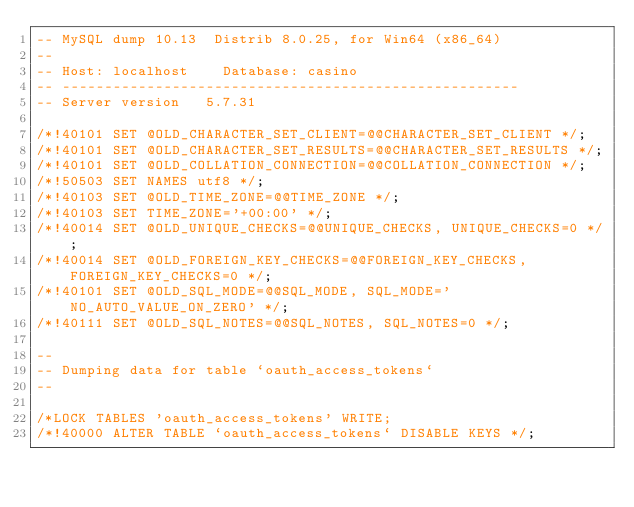<code> <loc_0><loc_0><loc_500><loc_500><_SQL_>-- MySQL dump 10.13  Distrib 8.0.25, for Win64 (x86_64)
--
-- Host: localhost    Database: casino
-- ------------------------------------------------------
-- Server version	5.7.31

/*!40101 SET @OLD_CHARACTER_SET_CLIENT=@@CHARACTER_SET_CLIENT */;
/*!40101 SET @OLD_CHARACTER_SET_RESULTS=@@CHARACTER_SET_RESULTS */;
/*!40101 SET @OLD_COLLATION_CONNECTION=@@COLLATION_CONNECTION */;
/*!50503 SET NAMES utf8 */;
/*!40103 SET @OLD_TIME_ZONE=@@TIME_ZONE */;
/*!40103 SET TIME_ZONE='+00:00' */;
/*!40014 SET @OLD_UNIQUE_CHECKS=@@UNIQUE_CHECKS, UNIQUE_CHECKS=0 */;
/*!40014 SET @OLD_FOREIGN_KEY_CHECKS=@@FOREIGN_KEY_CHECKS, FOREIGN_KEY_CHECKS=0 */;
/*!40101 SET @OLD_SQL_MODE=@@SQL_MODE, SQL_MODE='NO_AUTO_VALUE_ON_ZERO' */;
/*!40111 SET @OLD_SQL_NOTES=@@SQL_NOTES, SQL_NOTES=0 */;

--
-- Dumping data for table `oauth_access_tokens`
--

/*LOCK TABLES 'oauth_access_tokens' WRITE;
/*!40000 ALTER TABLE `oauth_access_tokens` DISABLE KEYS */;</code> 